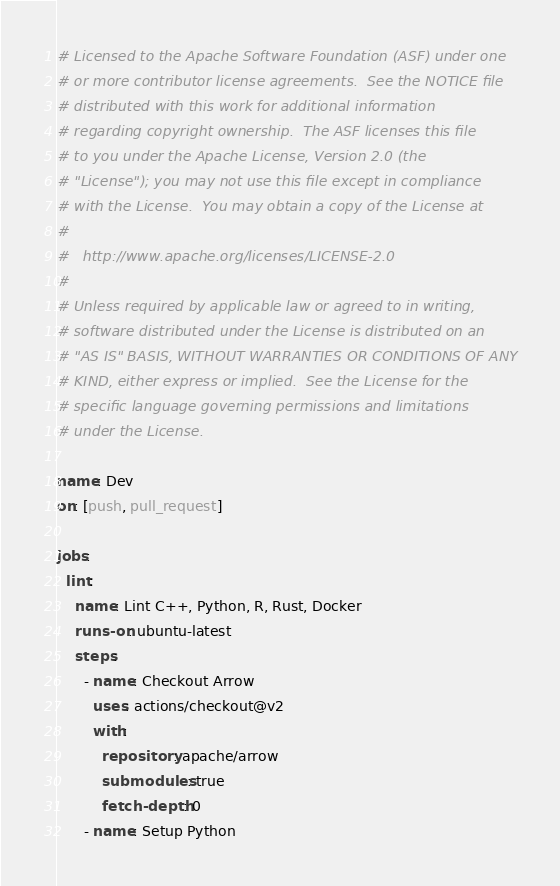Convert code to text. <code><loc_0><loc_0><loc_500><loc_500><_YAML_># Licensed to the Apache Software Foundation (ASF) under one
# or more contributor license agreements.  See the NOTICE file
# distributed with this work for additional information
# regarding copyright ownership.  The ASF licenses this file
# to you under the Apache License, Version 2.0 (the
# "License"); you may not use this file except in compliance
# with the License.  You may obtain a copy of the License at
#
#   http://www.apache.org/licenses/LICENSE-2.0
#
# Unless required by applicable law or agreed to in writing,
# software distributed under the License is distributed on an
# "AS IS" BASIS, WITHOUT WARRANTIES OR CONDITIONS OF ANY
# KIND, either express or implied.  See the License for the
# specific language governing permissions and limitations
# under the License.

name: Dev
on: [push, pull_request]

jobs:
  lint:
    name: Lint C++, Python, R, Rust, Docker
    runs-on: ubuntu-latest
    steps:
      - name: Checkout Arrow
        uses: actions/checkout@v2
        with:
          repository: apache/arrow
          submodules: true
          fetch-depth: 0
      - name: Setup Python</code> 